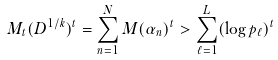<formula> <loc_0><loc_0><loc_500><loc_500>M _ { t } ( D ^ { 1 / k } ) ^ { t } = \sum _ { n = 1 } ^ { N } M ( \alpha _ { n } ) ^ { t } > \sum _ { \ell = 1 } ^ { L } ( \log p _ { \ell } ) ^ { t }</formula> 